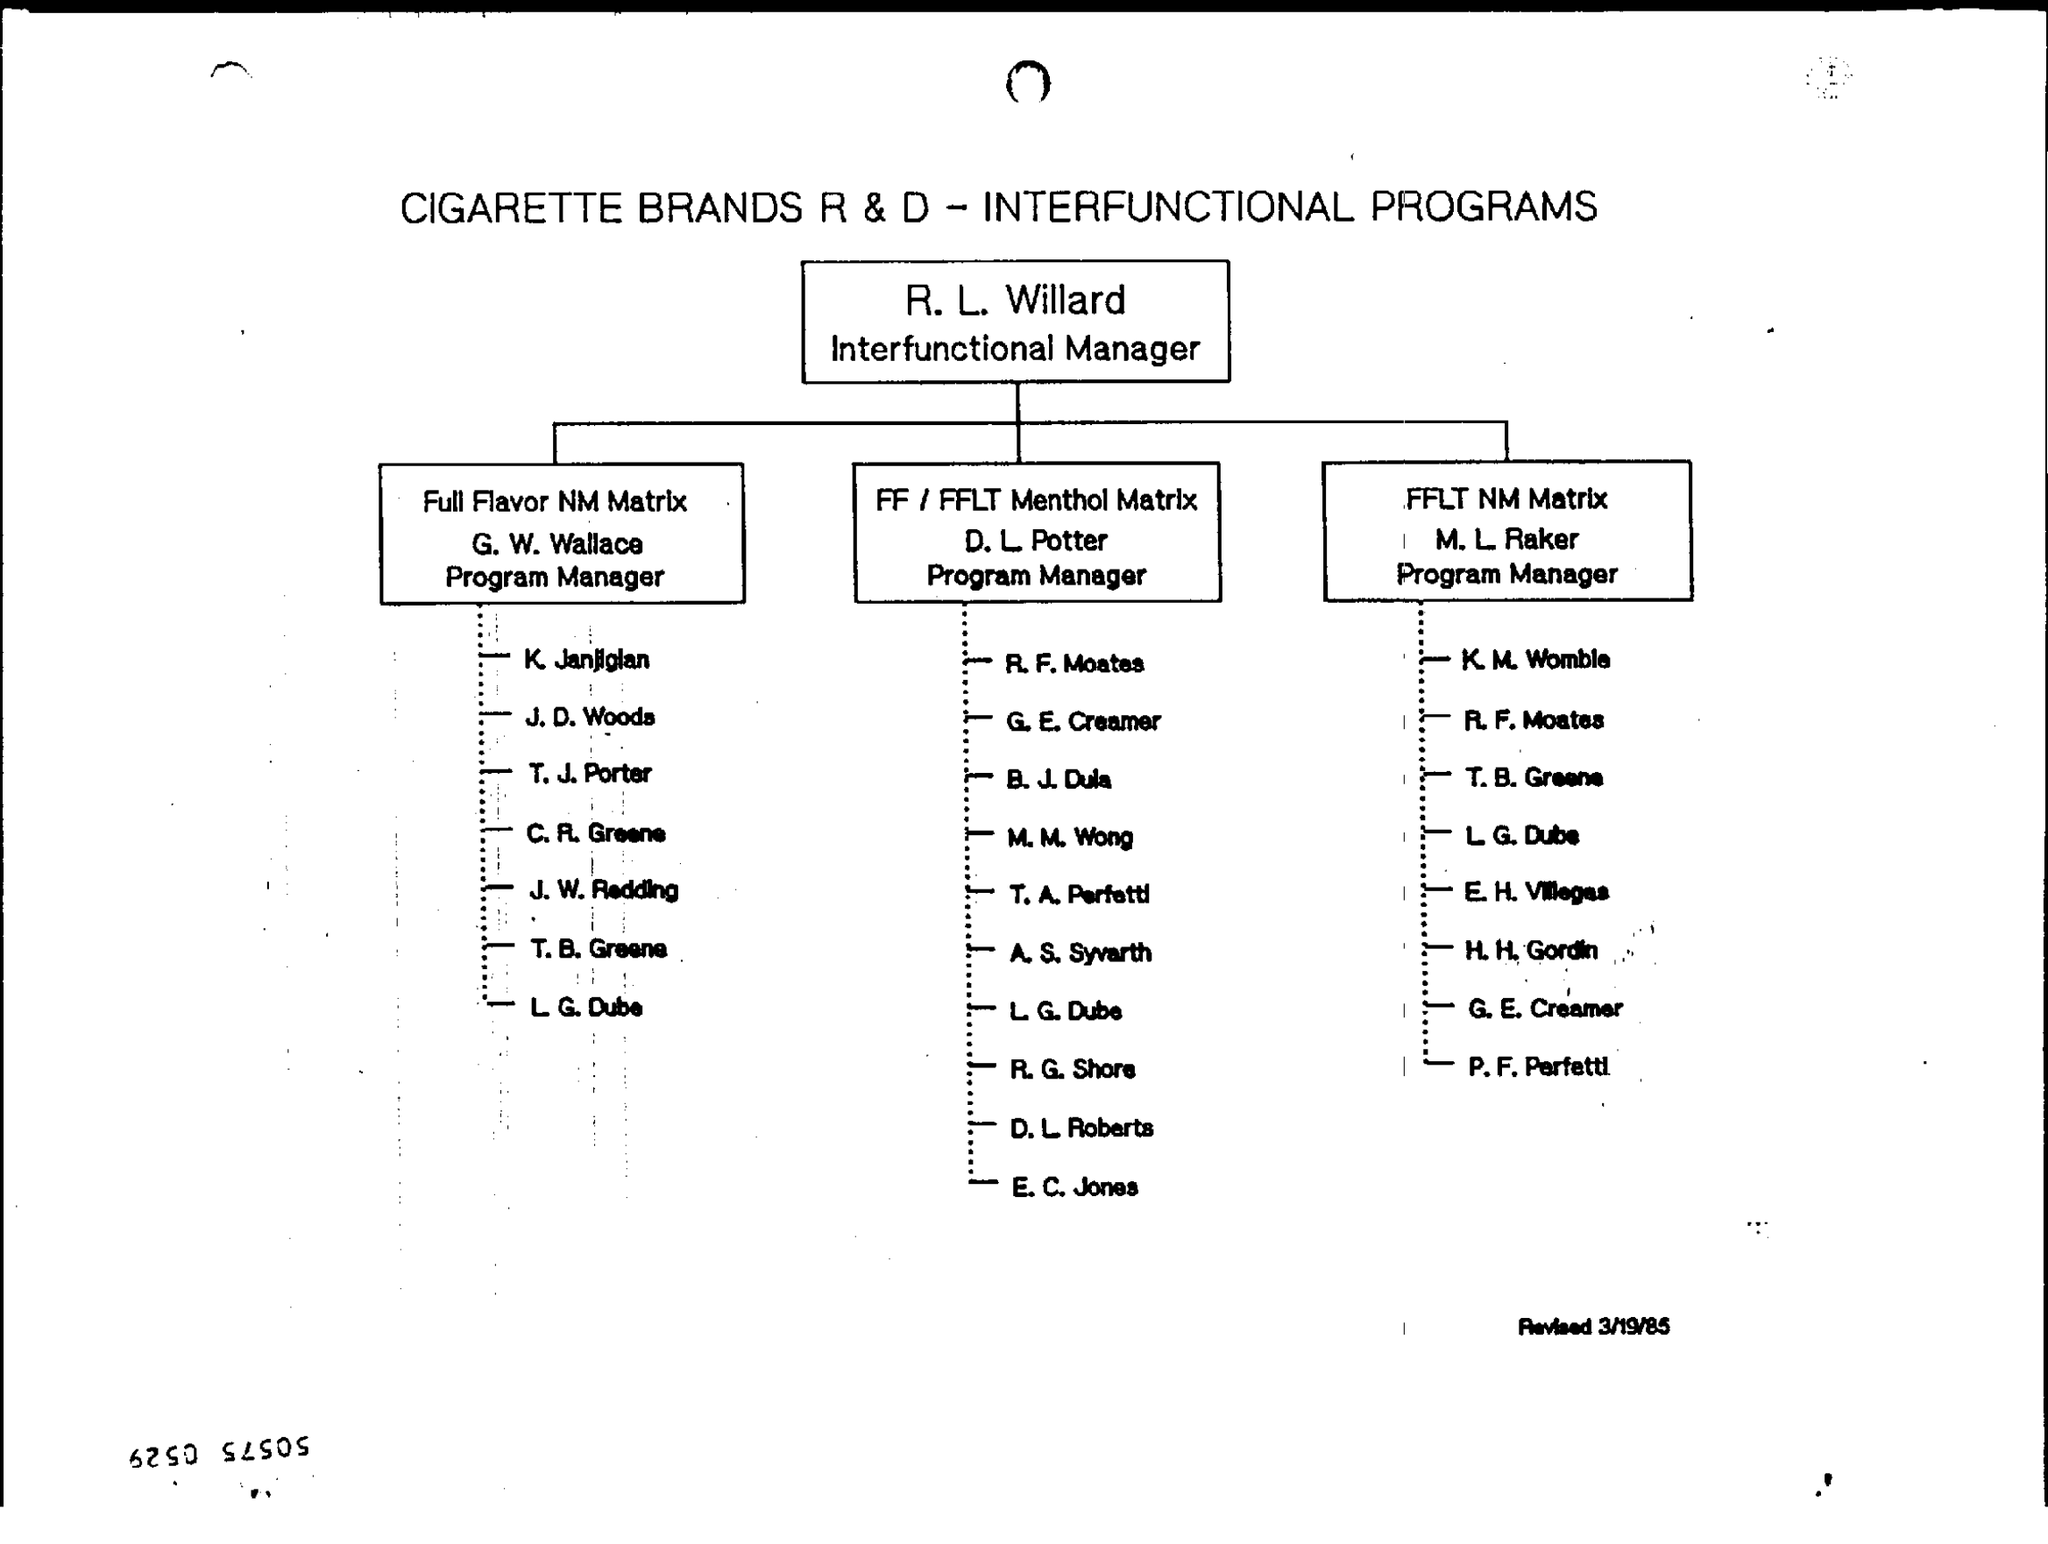Draw attention to some important aspects in this diagram. G. W. Wallace is the Program Manager of Full Flavor NM Matrix. The document title is "CIGARETTE BRANDS R&D - INTERFUNCTIONAL PROGRAMS. R. L. Willard's designation is that of an Interfunctional Manager. 